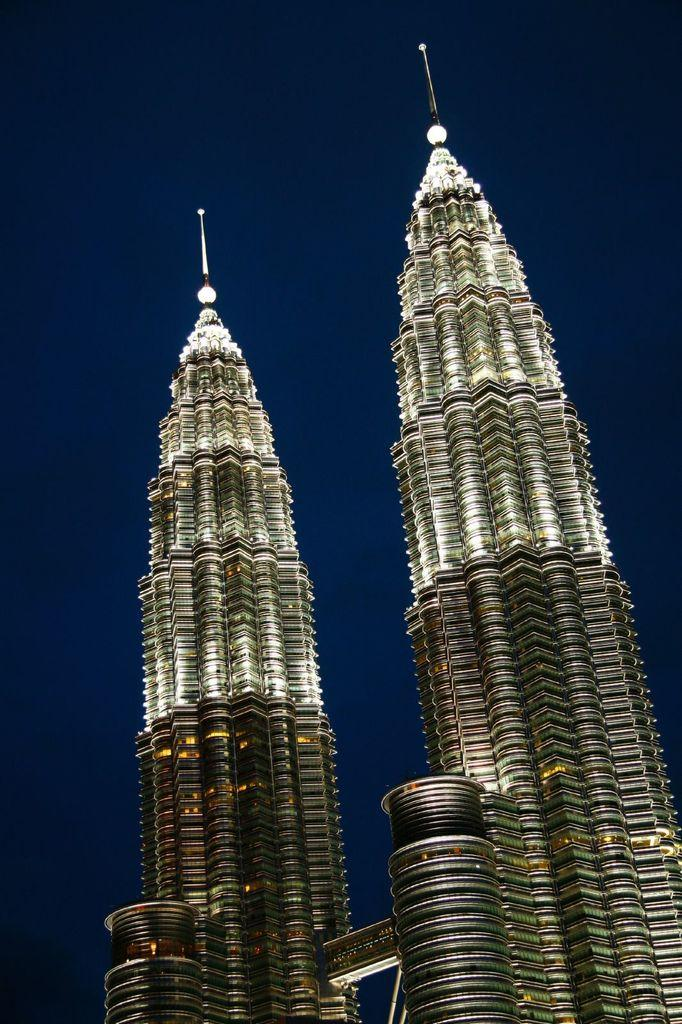What type of buildings are in the center of the image? There are two skyscrapers in the image. Can you describe the location of the skyscrapers in the image? The skyscrapers are in the center of the image. How many tickets does the boy hand out in the image? There is no boy or tickets present in the image. What type of farewell is depicted in the image? There is no farewell or good-bye scene present in the image. 